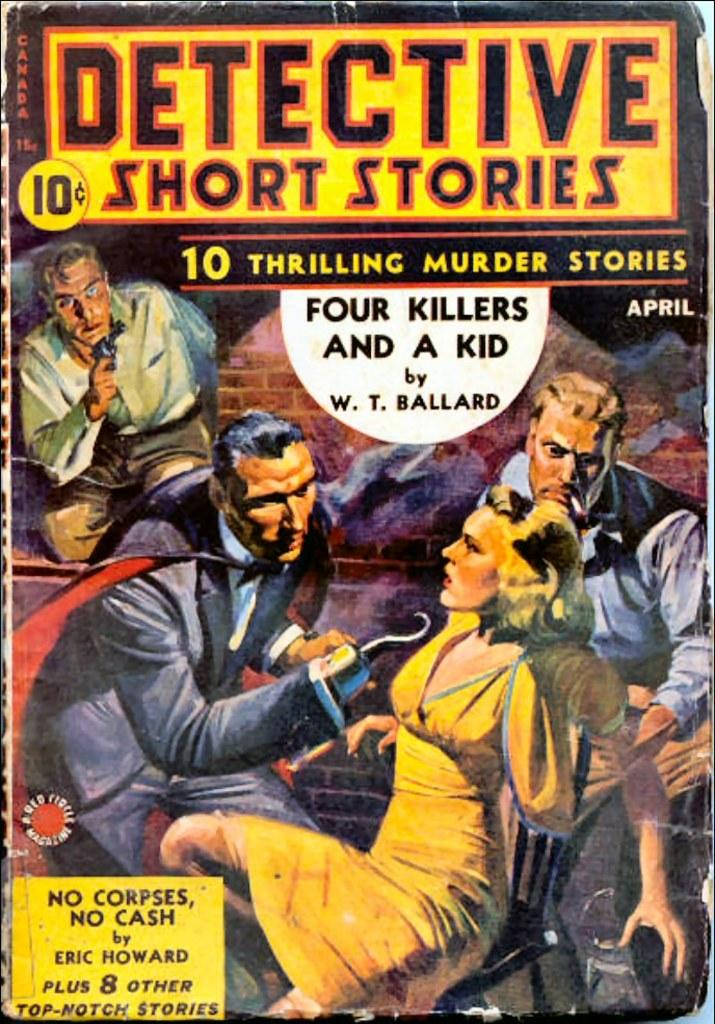<image>
Write a terse but informative summary of the picture. A pulp comic called Detective Short Stories for ten cents. 